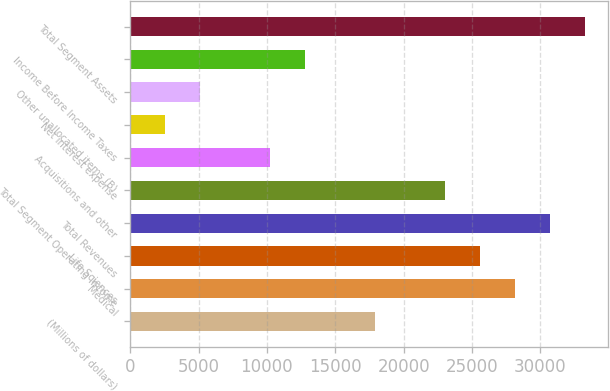Convert chart to OTSL. <chart><loc_0><loc_0><loc_500><loc_500><bar_chart><fcel>(Millions of dollars)<fcel>Medical<fcel>Life Sciences<fcel>Total Revenues<fcel>Total Segment Operating Income<fcel>Acquisitions and other<fcel>Net interest expense<fcel>Other unallocated items (B)<fcel>Income Before Income Taxes<fcel>Total Segment Assets<nl><fcel>17913.8<fcel>28143.4<fcel>25586<fcel>30700.8<fcel>23028.6<fcel>10241.6<fcel>2569.4<fcel>5126.8<fcel>12799<fcel>33258.2<nl></chart> 